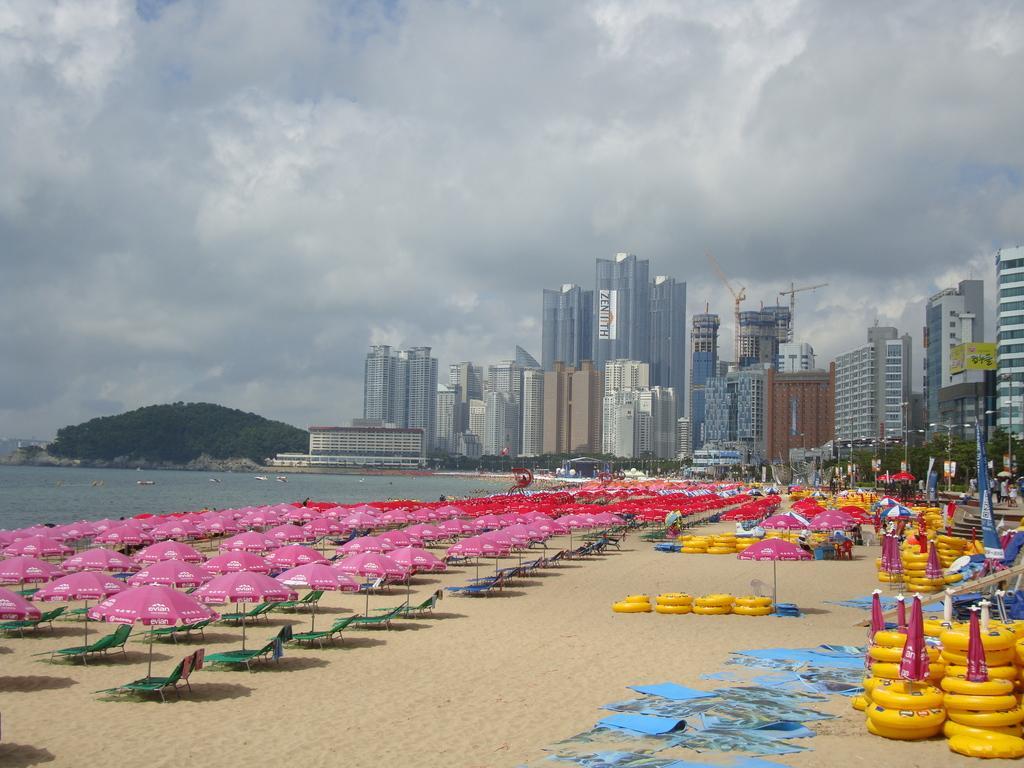Please provide a concise description of this image. In this image I can see chairs, umbrellas, buildings, trees and the water. In the background I can see the sky. Here I can see some yellow color objects on the ground. 